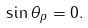<formula> <loc_0><loc_0><loc_500><loc_500>\sin \theta _ { p } = 0 .</formula> 